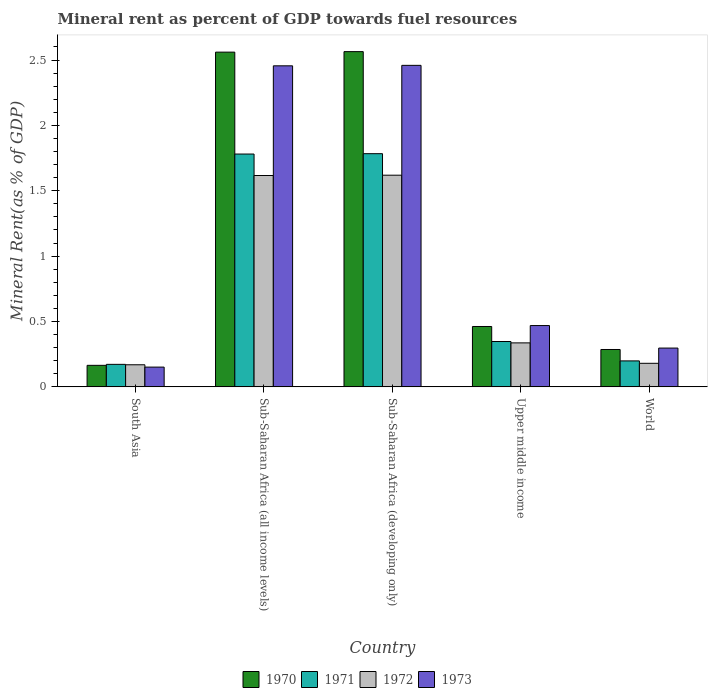How many groups of bars are there?
Provide a succinct answer. 5. How many bars are there on the 2nd tick from the right?
Offer a terse response. 4. What is the label of the 1st group of bars from the left?
Make the answer very short. South Asia. What is the mineral rent in 1971 in Sub-Saharan Africa (developing only)?
Your answer should be compact. 1.78. Across all countries, what is the maximum mineral rent in 1970?
Keep it short and to the point. 2.56. Across all countries, what is the minimum mineral rent in 1971?
Ensure brevity in your answer.  0.17. In which country was the mineral rent in 1971 maximum?
Offer a terse response. Sub-Saharan Africa (developing only). In which country was the mineral rent in 1973 minimum?
Keep it short and to the point. South Asia. What is the total mineral rent in 1972 in the graph?
Your response must be concise. 3.92. What is the difference between the mineral rent in 1973 in South Asia and that in World?
Provide a short and direct response. -0.15. What is the difference between the mineral rent in 1970 in South Asia and the mineral rent in 1972 in Sub-Saharan Africa (all income levels)?
Offer a terse response. -1.45. What is the average mineral rent in 1972 per country?
Offer a terse response. 0.78. What is the difference between the mineral rent of/in 1970 and mineral rent of/in 1972 in Upper middle income?
Ensure brevity in your answer.  0.13. What is the ratio of the mineral rent in 1972 in Sub-Saharan Africa (all income levels) to that in Upper middle income?
Provide a short and direct response. 4.81. Is the difference between the mineral rent in 1970 in Sub-Saharan Africa (developing only) and Upper middle income greater than the difference between the mineral rent in 1972 in Sub-Saharan Africa (developing only) and Upper middle income?
Provide a short and direct response. Yes. What is the difference between the highest and the second highest mineral rent in 1972?
Provide a succinct answer. -1.28. What is the difference between the highest and the lowest mineral rent in 1970?
Make the answer very short. 2.4. Is the sum of the mineral rent in 1971 in South Asia and Sub-Saharan Africa (all income levels) greater than the maximum mineral rent in 1970 across all countries?
Make the answer very short. No. What does the 3rd bar from the left in Sub-Saharan Africa (developing only) represents?
Offer a terse response. 1972. What does the 2nd bar from the right in Sub-Saharan Africa (all income levels) represents?
Offer a very short reply. 1972. How many bars are there?
Keep it short and to the point. 20. Are all the bars in the graph horizontal?
Offer a very short reply. No. What is the difference between two consecutive major ticks on the Y-axis?
Offer a terse response. 0.5. What is the title of the graph?
Offer a very short reply. Mineral rent as percent of GDP towards fuel resources. Does "1973" appear as one of the legend labels in the graph?
Your answer should be compact. Yes. What is the label or title of the Y-axis?
Your response must be concise. Mineral Rent(as % of GDP). What is the Mineral Rent(as % of GDP) of 1970 in South Asia?
Offer a terse response. 0.16. What is the Mineral Rent(as % of GDP) in 1971 in South Asia?
Make the answer very short. 0.17. What is the Mineral Rent(as % of GDP) in 1972 in South Asia?
Give a very brief answer. 0.17. What is the Mineral Rent(as % of GDP) in 1973 in South Asia?
Make the answer very short. 0.15. What is the Mineral Rent(as % of GDP) of 1970 in Sub-Saharan Africa (all income levels)?
Your answer should be very brief. 2.56. What is the Mineral Rent(as % of GDP) of 1971 in Sub-Saharan Africa (all income levels)?
Your answer should be very brief. 1.78. What is the Mineral Rent(as % of GDP) in 1972 in Sub-Saharan Africa (all income levels)?
Your answer should be compact. 1.62. What is the Mineral Rent(as % of GDP) in 1973 in Sub-Saharan Africa (all income levels)?
Provide a short and direct response. 2.46. What is the Mineral Rent(as % of GDP) of 1970 in Sub-Saharan Africa (developing only)?
Your answer should be very brief. 2.56. What is the Mineral Rent(as % of GDP) in 1971 in Sub-Saharan Africa (developing only)?
Offer a terse response. 1.78. What is the Mineral Rent(as % of GDP) of 1972 in Sub-Saharan Africa (developing only)?
Make the answer very short. 1.62. What is the Mineral Rent(as % of GDP) of 1973 in Sub-Saharan Africa (developing only)?
Provide a succinct answer. 2.46. What is the Mineral Rent(as % of GDP) of 1970 in Upper middle income?
Your answer should be compact. 0.46. What is the Mineral Rent(as % of GDP) in 1971 in Upper middle income?
Your answer should be compact. 0.35. What is the Mineral Rent(as % of GDP) of 1972 in Upper middle income?
Ensure brevity in your answer.  0.34. What is the Mineral Rent(as % of GDP) of 1973 in Upper middle income?
Keep it short and to the point. 0.47. What is the Mineral Rent(as % of GDP) in 1970 in World?
Your answer should be compact. 0.29. What is the Mineral Rent(as % of GDP) of 1971 in World?
Keep it short and to the point. 0.2. What is the Mineral Rent(as % of GDP) in 1972 in World?
Provide a short and direct response. 0.18. What is the Mineral Rent(as % of GDP) of 1973 in World?
Ensure brevity in your answer.  0.3. Across all countries, what is the maximum Mineral Rent(as % of GDP) in 1970?
Make the answer very short. 2.56. Across all countries, what is the maximum Mineral Rent(as % of GDP) of 1971?
Provide a short and direct response. 1.78. Across all countries, what is the maximum Mineral Rent(as % of GDP) in 1972?
Offer a terse response. 1.62. Across all countries, what is the maximum Mineral Rent(as % of GDP) in 1973?
Keep it short and to the point. 2.46. Across all countries, what is the minimum Mineral Rent(as % of GDP) in 1970?
Your answer should be compact. 0.16. Across all countries, what is the minimum Mineral Rent(as % of GDP) of 1971?
Your response must be concise. 0.17. Across all countries, what is the minimum Mineral Rent(as % of GDP) of 1972?
Your response must be concise. 0.17. Across all countries, what is the minimum Mineral Rent(as % of GDP) of 1973?
Keep it short and to the point. 0.15. What is the total Mineral Rent(as % of GDP) of 1970 in the graph?
Offer a very short reply. 6.04. What is the total Mineral Rent(as % of GDP) of 1971 in the graph?
Your answer should be compact. 4.28. What is the total Mineral Rent(as % of GDP) in 1972 in the graph?
Your answer should be very brief. 3.92. What is the total Mineral Rent(as % of GDP) of 1973 in the graph?
Ensure brevity in your answer.  5.83. What is the difference between the Mineral Rent(as % of GDP) in 1970 in South Asia and that in Sub-Saharan Africa (all income levels)?
Ensure brevity in your answer.  -2.4. What is the difference between the Mineral Rent(as % of GDP) of 1971 in South Asia and that in Sub-Saharan Africa (all income levels)?
Give a very brief answer. -1.61. What is the difference between the Mineral Rent(as % of GDP) of 1972 in South Asia and that in Sub-Saharan Africa (all income levels)?
Provide a short and direct response. -1.45. What is the difference between the Mineral Rent(as % of GDP) of 1973 in South Asia and that in Sub-Saharan Africa (all income levels)?
Ensure brevity in your answer.  -2.3. What is the difference between the Mineral Rent(as % of GDP) of 1970 in South Asia and that in Sub-Saharan Africa (developing only)?
Provide a short and direct response. -2.4. What is the difference between the Mineral Rent(as % of GDP) in 1971 in South Asia and that in Sub-Saharan Africa (developing only)?
Keep it short and to the point. -1.61. What is the difference between the Mineral Rent(as % of GDP) in 1972 in South Asia and that in Sub-Saharan Africa (developing only)?
Keep it short and to the point. -1.45. What is the difference between the Mineral Rent(as % of GDP) of 1973 in South Asia and that in Sub-Saharan Africa (developing only)?
Your answer should be very brief. -2.31. What is the difference between the Mineral Rent(as % of GDP) of 1970 in South Asia and that in Upper middle income?
Ensure brevity in your answer.  -0.3. What is the difference between the Mineral Rent(as % of GDP) of 1971 in South Asia and that in Upper middle income?
Provide a succinct answer. -0.17. What is the difference between the Mineral Rent(as % of GDP) in 1972 in South Asia and that in Upper middle income?
Your answer should be very brief. -0.17. What is the difference between the Mineral Rent(as % of GDP) of 1973 in South Asia and that in Upper middle income?
Make the answer very short. -0.32. What is the difference between the Mineral Rent(as % of GDP) of 1970 in South Asia and that in World?
Provide a succinct answer. -0.12. What is the difference between the Mineral Rent(as % of GDP) of 1971 in South Asia and that in World?
Give a very brief answer. -0.03. What is the difference between the Mineral Rent(as % of GDP) in 1972 in South Asia and that in World?
Your answer should be very brief. -0.01. What is the difference between the Mineral Rent(as % of GDP) of 1973 in South Asia and that in World?
Make the answer very short. -0.15. What is the difference between the Mineral Rent(as % of GDP) of 1970 in Sub-Saharan Africa (all income levels) and that in Sub-Saharan Africa (developing only)?
Make the answer very short. -0. What is the difference between the Mineral Rent(as % of GDP) in 1971 in Sub-Saharan Africa (all income levels) and that in Sub-Saharan Africa (developing only)?
Provide a short and direct response. -0. What is the difference between the Mineral Rent(as % of GDP) in 1972 in Sub-Saharan Africa (all income levels) and that in Sub-Saharan Africa (developing only)?
Your answer should be compact. -0. What is the difference between the Mineral Rent(as % of GDP) in 1973 in Sub-Saharan Africa (all income levels) and that in Sub-Saharan Africa (developing only)?
Offer a very short reply. -0. What is the difference between the Mineral Rent(as % of GDP) of 1970 in Sub-Saharan Africa (all income levels) and that in Upper middle income?
Offer a terse response. 2.1. What is the difference between the Mineral Rent(as % of GDP) in 1971 in Sub-Saharan Africa (all income levels) and that in Upper middle income?
Offer a very short reply. 1.43. What is the difference between the Mineral Rent(as % of GDP) in 1972 in Sub-Saharan Africa (all income levels) and that in Upper middle income?
Ensure brevity in your answer.  1.28. What is the difference between the Mineral Rent(as % of GDP) in 1973 in Sub-Saharan Africa (all income levels) and that in Upper middle income?
Make the answer very short. 1.99. What is the difference between the Mineral Rent(as % of GDP) of 1970 in Sub-Saharan Africa (all income levels) and that in World?
Offer a very short reply. 2.27. What is the difference between the Mineral Rent(as % of GDP) in 1971 in Sub-Saharan Africa (all income levels) and that in World?
Offer a very short reply. 1.58. What is the difference between the Mineral Rent(as % of GDP) of 1972 in Sub-Saharan Africa (all income levels) and that in World?
Your answer should be compact. 1.44. What is the difference between the Mineral Rent(as % of GDP) in 1973 in Sub-Saharan Africa (all income levels) and that in World?
Provide a short and direct response. 2.16. What is the difference between the Mineral Rent(as % of GDP) of 1970 in Sub-Saharan Africa (developing only) and that in Upper middle income?
Ensure brevity in your answer.  2.1. What is the difference between the Mineral Rent(as % of GDP) of 1971 in Sub-Saharan Africa (developing only) and that in Upper middle income?
Provide a short and direct response. 1.44. What is the difference between the Mineral Rent(as % of GDP) of 1972 in Sub-Saharan Africa (developing only) and that in Upper middle income?
Your response must be concise. 1.28. What is the difference between the Mineral Rent(as % of GDP) of 1973 in Sub-Saharan Africa (developing only) and that in Upper middle income?
Keep it short and to the point. 1.99. What is the difference between the Mineral Rent(as % of GDP) of 1970 in Sub-Saharan Africa (developing only) and that in World?
Provide a short and direct response. 2.28. What is the difference between the Mineral Rent(as % of GDP) of 1971 in Sub-Saharan Africa (developing only) and that in World?
Provide a short and direct response. 1.58. What is the difference between the Mineral Rent(as % of GDP) of 1972 in Sub-Saharan Africa (developing only) and that in World?
Offer a terse response. 1.44. What is the difference between the Mineral Rent(as % of GDP) in 1973 in Sub-Saharan Africa (developing only) and that in World?
Your response must be concise. 2.16. What is the difference between the Mineral Rent(as % of GDP) in 1970 in Upper middle income and that in World?
Give a very brief answer. 0.18. What is the difference between the Mineral Rent(as % of GDP) of 1971 in Upper middle income and that in World?
Ensure brevity in your answer.  0.15. What is the difference between the Mineral Rent(as % of GDP) in 1972 in Upper middle income and that in World?
Ensure brevity in your answer.  0.16. What is the difference between the Mineral Rent(as % of GDP) of 1973 in Upper middle income and that in World?
Your answer should be very brief. 0.17. What is the difference between the Mineral Rent(as % of GDP) in 1970 in South Asia and the Mineral Rent(as % of GDP) in 1971 in Sub-Saharan Africa (all income levels)?
Make the answer very short. -1.62. What is the difference between the Mineral Rent(as % of GDP) in 1970 in South Asia and the Mineral Rent(as % of GDP) in 1972 in Sub-Saharan Africa (all income levels)?
Provide a succinct answer. -1.45. What is the difference between the Mineral Rent(as % of GDP) of 1970 in South Asia and the Mineral Rent(as % of GDP) of 1973 in Sub-Saharan Africa (all income levels)?
Provide a short and direct response. -2.29. What is the difference between the Mineral Rent(as % of GDP) in 1971 in South Asia and the Mineral Rent(as % of GDP) in 1972 in Sub-Saharan Africa (all income levels)?
Your response must be concise. -1.44. What is the difference between the Mineral Rent(as % of GDP) of 1971 in South Asia and the Mineral Rent(as % of GDP) of 1973 in Sub-Saharan Africa (all income levels)?
Provide a short and direct response. -2.28. What is the difference between the Mineral Rent(as % of GDP) of 1972 in South Asia and the Mineral Rent(as % of GDP) of 1973 in Sub-Saharan Africa (all income levels)?
Your answer should be very brief. -2.29. What is the difference between the Mineral Rent(as % of GDP) of 1970 in South Asia and the Mineral Rent(as % of GDP) of 1971 in Sub-Saharan Africa (developing only)?
Keep it short and to the point. -1.62. What is the difference between the Mineral Rent(as % of GDP) in 1970 in South Asia and the Mineral Rent(as % of GDP) in 1972 in Sub-Saharan Africa (developing only)?
Offer a very short reply. -1.45. What is the difference between the Mineral Rent(as % of GDP) in 1970 in South Asia and the Mineral Rent(as % of GDP) in 1973 in Sub-Saharan Africa (developing only)?
Offer a terse response. -2.29. What is the difference between the Mineral Rent(as % of GDP) of 1971 in South Asia and the Mineral Rent(as % of GDP) of 1972 in Sub-Saharan Africa (developing only)?
Your answer should be compact. -1.45. What is the difference between the Mineral Rent(as % of GDP) of 1971 in South Asia and the Mineral Rent(as % of GDP) of 1973 in Sub-Saharan Africa (developing only)?
Make the answer very short. -2.29. What is the difference between the Mineral Rent(as % of GDP) of 1972 in South Asia and the Mineral Rent(as % of GDP) of 1973 in Sub-Saharan Africa (developing only)?
Offer a terse response. -2.29. What is the difference between the Mineral Rent(as % of GDP) in 1970 in South Asia and the Mineral Rent(as % of GDP) in 1971 in Upper middle income?
Provide a succinct answer. -0.18. What is the difference between the Mineral Rent(as % of GDP) in 1970 in South Asia and the Mineral Rent(as % of GDP) in 1972 in Upper middle income?
Your answer should be compact. -0.17. What is the difference between the Mineral Rent(as % of GDP) of 1970 in South Asia and the Mineral Rent(as % of GDP) of 1973 in Upper middle income?
Give a very brief answer. -0.3. What is the difference between the Mineral Rent(as % of GDP) in 1971 in South Asia and the Mineral Rent(as % of GDP) in 1972 in Upper middle income?
Offer a very short reply. -0.16. What is the difference between the Mineral Rent(as % of GDP) of 1971 in South Asia and the Mineral Rent(as % of GDP) of 1973 in Upper middle income?
Offer a very short reply. -0.3. What is the difference between the Mineral Rent(as % of GDP) of 1972 in South Asia and the Mineral Rent(as % of GDP) of 1973 in Upper middle income?
Keep it short and to the point. -0.3. What is the difference between the Mineral Rent(as % of GDP) in 1970 in South Asia and the Mineral Rent(as % of GDP) in 1971 in World?
Make the answer very short. -0.03. What is the difference between the Mineral Rent(as % of GDP) in 1970 in South Asia and the Mineral Rent(as % of GDP) in 1972 in World?
Your answer should be compact. -0.02. What is the difference between the Mineral Rent(as % of GDP) of 1970 in South Asia and the Mineral Rent(as % of GDP) of 1973 in World?
Your answer should be very brief. -0.13. What is the difference between the Mineral Rent(as % of GDP) in 1971 in South Asia and the Mineral Rent(as % of GDP) in 1972 in World?
Offer a very short reply. -0.01. What is the difference between the Mineral Rent(as % of GDP) in 1971 in South Asia and the Mineral Rent(as % of GDP) in 1973 in World?
Your answer should be very brief. -0.12. What is the difference between the Mineral Rent(as % of GDP) in 1972 in South Asia and the Mineral Rent(as % of GDP) in 1973 in World?
Provide a short and direct response. -0.13. What is the difference between the Mineral Rent(as % of GDP) in 1970 in Sub-Saharan Africa (all income levels) and the Mineral Rent(as % of GDP) in 1971 in Sub-Saharan Africa (developing only)?
Provide a succinct answer. 0.78. What is the difference between the Mineral Rent(as % of GDP) in 1970 in Sub-Saharan Africa (all income levels) and the Mineral Rent(as % of GDP) in 1973 in Sub-Saharan Africa (developing only)?
Your answer should be compact. 0.1. What is the difference between the Mineral Rent(as % of GDP) of 1971 in Sub-Saharan Africa (all income levels) and the Mineral Rent(as % of GDP) of 1972 in Sub-Saharan Africa (developing only)?
Offer a terse response. 0.16. What is the difference between the Mineral Rent(as % of GDP) of 1971 in Sub-Saharan Africa (all income levels) and the Mineral Rent(as % of GDP) of 1973 in Sub-Saharan Africa (developing only)?
Keep it short and to the point. -0.68. What is the difference between the Mineral Rent(as % of GDP) in 1972 in Sub-Saharan Africa (all income levels) and the Mineral Rent(as % of GDP) in 1973 in Sub-Saharan Africa (developing only)?
Provide a succinct answer. -0.84. What is the difference between the Mineral Rent(as % of GDP) in 1970 in Sub-Saharan Africa (all income levels) and the Mineral Rent(as % of GDP) in 1971 in Upper middle income?
Your response must be concise. 2.21. What is the difference between the Mineral Rent(as % of GDP) in 1970 in Sub-Saharan Africa (all income levels) and the Mineral Rent(as % of GDP) in 1972 in Upper middle income?
Offer a terse response. 2.22. What is the difference between the Mineral Rent(as % of GDP) of 1970 in Sub-Saharan Africa (all income levels) and the Mineral Rent(as % of GDP) of 1973 in Upper middle income?
Ensure brevity in your answer.  2.09. What is the difference between the Mineral Rent(as % of GDP) in 1971 in Sub-Saharan Africa (all income levels) and the Mineral Rent(as % of GDP) in 1972 in Upper middle income?
Your answer should be compact. 1.44. What is the difference between the Mineral Rent(as % of GDP) in 1971 in Sub-Saharan Africa (all income levels) and the Mineral Rent(as % of GDP) in 1973 in Upper middle income?
Keep it short and to the point. 1.31. What is the difference between the Mineral Rent(as % of GDP) of 1972 in Sub-Saharan Africa (all income levels) and the Mineral Rent(as % of GDP) of 1973 in Upper middle income?
Keep it short and to the point. 1.15. What is the difference between the Mineral Rent(as % of GDP) in 1970 in Sub-Saharan Africa (all income levels) and the Mineral Rent(as % of GDP) in 1971 in World?
Make the answer very short. 2.36. What is the difference between the Mineral Rent(as % of GDP) in 1970 in Sub-Saharan Africa (all income levels) and the Mineral Rent(as % of GDP) in 1972 in World?
Make the answer very short. 2.38. What is the difference between the Mineral Rent(as % of GDP) in 1970 in Sub-Saharan Africa (all income levels) and the Mineral Rent(as % of GDP) in 1973 in World?
Give a very brief answer. 2.26. What is the difference between the Mineral Rent(as % of GDP) of 1971 in Sub-Saharan Africa (all income levels) and the Mineral Rent(as % of GDP) of 1972 in World?
Offer a terse response. 1.6. What is the difference between the Mineral Rent(as % of GDP) in 1971 in Sub-Saharan Africa (all income levels) and the Mineral Rent(as % of GDP) in 1973 in World?
Provide a short and direct response. 1.48. What is the difference between the Mineral Rent(as % of GDP) in 1972 in Sub-Saharan Africa (all income levels) and the Mineral Rent(as % of GDP) in 1973 in World?
Keep it short and to the point. 1.32. What is the difference between the Mineral Rent(as % of GDP) of 1970 in Sub-Saharan Africa (developing only) and the Mineral Rent(as % of GDP) of 1971 in Upper middle income?
Make the answer very short. 2.22. What is the difference between the Mineral Rent(as % of GDP) of 1970 in Sub-Saharan Africa (developing only) and the Mineral Rent(as % of GDP) of 1972 in Upper middle income?
Offer a terse response. 2.23. What is the difference between the Mineral Rent(as % of GDP) of 1970 in Sub-Saharan Africa (developing only) and the Mineral Rent(as % of GDP) of 1973 in Upper middle income?
Make the answer very short. 2.1. What is the difference between the Mineral Rent(as % of GDP) in 1971 in Sub-Saharan Africa (developing only) and the Mineral Rent(as % of GDP) in 1972 in Upper middle income?
Your answer should be compact. 1.45. What is the difference between the Mineral Rent(as % of GDP) of 1971 in Sub-Saharan Africa (developing only) and the Mineral Rent(as % of GDP) of 1973 in Upper middle income?
Give a very brief answer. 1.31. What is the difference between the Mineral Rent(as % of GDP) of 1972 in Sub-Saharan Africa (developing only) and the Mineral Rent(as % of GDP) of 1973 in Upper middle income?
Give a very brief answer. 1.15. What is the difference between the Mineral Rent(as % of GDP) of 1970 in Sub-Saharan Africa (developing only) and the Mineral Rent(as % of GDP) of 1971 in World?
Make the answer very short. 2.37. What is the difference between the Mineral Rent(as % of GDP) of 1970 in Sub-Saharan Africa (developing only) and the Mineral Rent(as % of GDP) of 1972 in World?
Provide a succinct answer. 2.38. What is the difference between the Mineral Rent(as % of GDP) of 1970 in Sub-Saharan Africa (developing only) and the Mineral Rent(as % of GDP) of 1973 in World?
Ensure brevity in your answer.  2.27. What is the difference between the Mineral Rent(as % of GDP) of 1971 in Sub-Saharan Africa (developing only) and the Mineral Rent(as % of GDP) of 1972 in World?
Offer a terse response. 1.6. What is the difference between the Mineral Rent(as % of GDP) of 1971 in Sub-Saharan Africa (developing only) and the Mineral Rent(as % of GDP) of 1973 in World?
Your answer should be compact. 1.49. What is the difference between the Mineral Rent(as % of GDP) of 1972 in Sub-Saharan Africa (developing only) and the Mineral Rent(as % of GDP) of 1973 in World?
Your response must be concise. 1.32. What is the difference between the Mineral Rent(as % of GDP) in 1970 in Upper middle income and the Mineral Rent(as % of GDP) in 1971 in World?
Make the answer very short. 0.26. What is the difference between the Mineral Rent(as % of GDP) of 1970 in Upper middle income and the Mineral Rent(as % of GDP) of 1972 in World?
Your answer should be very brief. 0.28. What is the difference between the Mineral Rent(as % of GDP) in 1970 in Upper middle income and the Mineral Rent(as % of GDP) in 1973 in World?
Your answer should be very brief. 0.17. What is the difference between the Mineral Rent(as % of GDP) in 1971 in Upper middle income and the Mineral Rent(as % of GDP) in 1973 in World?
Provide a short and direct response. 0.05. What is the difference between the Mineral Rent(as % of GDP) in 1972 in Upper middle income and the Mineral Rent(as % of GDP) in 1973 in World?
Keep it short and to the point. 0.04. What is the average Mineral Rent(as % of GDP) of 1970 per country?
Offer a terse response. 1.21. What is the average Mineral Rent(as % of GDP) of 1971 per country?
Offer a very short reply. 0.86. What is the average Mineral Rent(as % of GDP) in 1972 per country?
Your response must be concise. 0.78. What is the average Mineral Rent(as % of GDP) in 1973 per country?
Make the answer very short. 1.17. What is the difference between the Mineral Rent(as % of GDP) of 1970 and Mineral Rent(as % of GDP) of 1971 in South Asia?
Your answer should be very brief. -0.01. What is the difference between the Mineral Rent(as % of GDP) in 1970 and Mineral Rent(as % of GDP) in 1972 in South Asia?
Ensure brevity in your answer.  -0. What is the difference between the Mineral Rent(as % of GDP) of 1970 and Mineral Rent(as % of GDP) of 1973 in South Asia?
Provide a succinct answer. 0.01. What is the difference between the Mineral Rent(as % of GDP) of 1971 and Mineral Rent(as % of GDP) of 1972 in South Asia?
Your answer should be very brief. 0. What is the difference between the Mineral Rent(as % of GDP) in 1971 and Mineral Rent(as % of GDP) in 1973 in South Asia?
Your answer should be very brief. 0.02. What is the difference between the Mineral Rent(as % of GDP) in 1972 and Mineral Rent(as % of GDP) in 1973 in South Asia?
Give a very brief answer. 0.02. What is the difference between the Mineral Rent(as % of GDP) in 1970 and Mineral Rent(as % of GDP) in 1971 in Sub-Saharan Africa (all income levels)?
Your answer should be very brief. 0.78. What is the difference between the Mineral Rent(as % of GDP) in 1970 and Mineral Rent(as % of GDP) in 1972 in Sub-Saharan Africa (all income levels)?
Offer a terse response. 0.94. What is the difference between the Mineral Rent(as % of GDP) of 1970 and Mineral Rent(as % of GDP) of 1973 in Sub-Saharan Africa (all income levels)?
Your answer should be very brief. 0.1. What is the difference between the Mineral Rent(as % of GDP) of 1971 and Mineral Rent(as % of GDP) of 1972 in Sub-Saharan Africa (all income levels)?
Your answer should be very brief. 0.16. What is the difference between the Mineral Rent(as % of GDP) of 1971 and Mineral Rent(as % of GDP) of 1973 in Sub-Saharan Africa (all income levels)?
Your response must be concise. -0.67. What is the difference between the Mineral Rent(as % of GDP) in 1972 and Mineral Rent(as % of GDP) in 1973 in Sub-Saharan Africa (all income levels)?
Ensure brevity in your answer.  -0.84. What is the difference between the Mineral Rent(as % of GDP) of 1970 and Mineral Rent(as % of GDP) of 1971 in Sub-Saharan Africa (developing only)?
Offer a very short reply. 0.78. What is the difference between the Mineral Rent(as % of GDP) of 1970 and Mineral Rent(as % of GDP) of 1972 in Sub-Saharan Africa (developing only)?
Give a very brief answer. 0.95. What is the difference between the Mineral Rent(as % of GDP) of 1970 and Mineral Rent(as % of GDP) of 1973 in Sub-Saharan Africa (developing only)?
Make the answer very short. 0.1. What is the difference between the Mineral Rent(as % of GDP) in 1971 and Mineral Rent(as % of GDP) in 1972 in Sub-Saharan Africa (developing only)?
Keep it short and to the point. 0.16. What is the difference between the Mineral Rent(as % of GDP) of 1971 and Mineral Rent(as % of GDP) of 1973 in Sub-Saharan Africa (developing only)?
Provide a short and direct response. -0.68. What is the difference between the Mineral Rent(as % of GDP) of 1972 and Mineral Rent(as % of GDP) of 1973 in Sub-Saharan Africa (developing only)?
Ensure brevity in your answer.  -0.84. What is the difference between the Mineral Rent(as % of GDP) of 1970 and Mineral Rent(as % of GDP) of 1971 in Upper middle income?
Make the answer very short. 0.11. What is the difference between the Mineral Rent(as % of GDP) in 1970 and Mineral Rent(as % of GDP) in 1972 in Upper middle income?
Keep it short and to the point. 0.13. What is the difference between the Mineral Rent(as % of GDP) of 1970 and Mineral Rent(as % of GDP) of 1973 in Upper middle income?
Offer a terse response. -0.01. What is the difference between the Mineral Rent(as % of GDP) in 1971 and Mineral Rent(as % of GDP) in 1972 in Upper middle income?
Give a very brief answer. 0.01. What is the difference between the Mineral Rent(as % of GDP) in 1971 and Mineral Rent(as % of GDP) in 1973 in Upper middle income?
Offer a terse response. -0.12. What is the difference between the Mineral Rent(as % of GDP) of 1972 and Mineral Rent(as % of GDP) of 1973 in Upper middle income?
Your response must be concise. -0.13. What is the difference between the Mineral Rent(as % of GDP) of 1970 and Mineral Rent(as % of GDP) of 1971 in World?
Keep it short and to the point. 0.09. What is the difference between the Mineral Rent(as % of GDP) of 1970 and Mineral Rent(as % of GDP) of 1972 in World?
Make the answer very short. 0.11. What is the difference between the Mineral Rent(as % of GDP) in 1970 and Mineral Rent(as % of GDP) in 1973 in World?
Keep it short and to the point. -0.01. What is the difference between the Mineral Rent(as % of GDP) in 1971 and Mineral Rent(as % of GDP) in 1972 in World?
Provide a short and direct response. 0.02. What is the difference between the Mineral Rent(as % of GDP) in 1971 and Mineral Rent(as % of GDP) in 1973 in World?
Your answer should be compact. -0.1. What is the difference between the Mineral Rent(as % of GDP) in 1972 and Mineral Rent(as % of GDP) in 1973 in World?
Offer a terse response. -0.12. What is the ratio of the Mineral Rent(as % of GDP) of 1970 in South Asia to that in Sub-Saharan Africa (all income levels)?
Ensure brevity in your answer.  0.06. What is the ratio of the Mineral Rent(as % of GDP) in 1971 in South Asia to that in Sub-Saharan Africa (all income levels)?
Offer a terse response. 0.1. What is the ratio of the Mineral Rent(as % of GDP) in 1972 in South Asia to that in Sub-Saharan Africa (all income levels)?
Offer a very short reply. 0.1. What is the ratio of the Mineral Rent(as % of GDP) in 1973 in South Asia to that in Sub-Saharan Africa (all income levels)?
Ensure brevity in your answer.  0.06. What is the ratio of the Mineral Rent(as % of GDP) of 1970 in South Asia to that in Sub-Saharan Africa (developing only)?
Your answer should be very brief. 0.06. What is the ratio of the Mineral Rent(as % of GDP) in 1971 in South Asia to that in Sub-Saharan Africa (developing only)?
Give a very brief answer. 0.1. What is the ratio of the Mineral Rent(as % of GDP) in 1972 in South Asia to that in Sub-Saharan Africa (developing only)?
Provide a short and direct response. 0.1. What is the ratio of the Mineral Rent(as % of GDP) in 1973 in South Asia to that in Sub-Saharan Africa (developing only)?
Your answer should be compact. 0.06. What is the ratio of the Mineral Rent(as % of GDP) of 1970 in South Asia to that in Upper middle income?
Ensure brevity in your answer.  0.36. What is the ratio of the Mineral Rent(as % of GDP) of 1971 in South Asia to that in Upper middle income?
Keep it short and to the point. 0.5. What is the ratio of the Mineral Rent(as % of GDP) in 1972 in South Asia to that in Upper middle income?
Offer a very short reply. 0.5. What is the ratio of the Mineral Rent(as % of GDP) in 1973 in South Asia to that in Upper middle income?
Make the answer very short. 0.32. What is the ratio of the Mineral Rent(as % of GDP) in 1970 in South Asia to that in World?
Offer a terse response. 0.58. What is the ratio of the Mineral Rent(as % of GDP) in 1971 in South Asia to that in World?
Your response must be concise. 0.87. What is the ratio of the Mineral Rent(as % of GDP) of 1972 in South Asia to that in World?
Ensure brevity in your answer.  0.94. What is the ratio of the Mineral Rent(as % of GDP) in 1973 in South Asia to that in World?
Your answer should be compact. 0.51. What is the ratio of the Mineral Rent(as % of GDP) in 1972 in Sub-Saharan Africa (all income levels) to that in Sub-Saharan Africa (developing only)?
Your answer should be compact. 1. What is the ratio of the Mineral Rent(as % of GDP) of 1970 in Sub-Saharan Africa (all income levels) to that in Upper middle income?
Your answer should be very brief. 5.54. What is the ratio of the Mineral Rent(as % of GDP) of 1971 in Sub-Saharan Africa (all income levels) to that in Upper middle income?
Your response must be concise. 5.13. What is the ratio of the Mineral Rent(as % of GDP) in 1972 in Sub-Saharan Africa (all income levels) to that in Upper middle income?
Your answer should be very brief. 4.81. What is the ratio of the Mineral Rent(as % of GDP) of 1973 in Sub-Saharan Africa (all income levels) to that in Upper middle income?
Your response must be concise. 5.24. What is the ratio of the Mineral Rent(as % of GDP) of 1970 in Sub-Saharan Africa (all income levels) to that in World?
Give a very brief answer. 8.95. What is the ratio of the Mineral Rent(as % of GDP) of 1971 in Sub-Saharan Africa (all income levels) to that in World?
Offer a very short reply. 8.97. What is the ratio of the Mineral Rent(as % of GDP) in 1972 in Sub-Saharan Africa (all income levels) to that in World?
Your response must be concise. 8.97. What is the ratio of the Mineral Rent(as % of GDP) of 1973 in Sub-Saharan Africa (all income levels) to that in World?
Your answer should be very brief. 8.28. What is the ratio of the Mineral Rent(as % of GDP) in 1970 in Sub-Saharan Africa (developing only) to that in Upper middle income?
Your answer should be compact. 5.55. What is the ratio of the Mineral Rent(as % of GDP) in 1971 in Sub-Saharan Africa (developing only) to that in Upper middle income?
Keep it short and to the point. 5.14. What is the ratio of the Mineral Rent(as % of GDP) in 1972 in Sub-Saharan Africa (developing only) to that in Upper middle income?
Your response must be concise. 4.81. What is the ratio of the Mineral Rent(as % of GDP) of 1973 in Sub-Saharan Africa (developing only) to that in Upper middle income?
Your answer should be very brief. 5.24. What is the ratio of the Mineral Rent(as % of GDP) of 1970 in Sub-Saharan Africa (developing only) to that in World?
Your response must be concise. 8.97. What is the ratio of the Mineral Rent(as % of GDP) of 1971 in Sub-Saharan Africa (developing only) to that in World?
Give a very brief answer. 8.98. What is the ratio of the Mineral Rent(as % of GDP) of 1972 in Sub-Saharan Africa (developing only) to that in World?
Make the answer very short. 8.98. What is the ratio of the Mineral Rent(as % of GDP) in 1973 in Sub-Saharan Africa (developing only) to that in World?
Give a very brief answer. 8.29. What is the ratio of the Mineral Rent(as % of GDP) of 1970 in Upper middle income to that in World?
Make the answer very short. 1.62. What is the ratio of the Mineral Rent(as % of GDP) in 1971 in Upper middle income to that in World?
Ensure brevity in your answer.  1.75. What is the ratio of the Mineral Rent(as % of GDP) in 1972 in Upper middle income to that in World?
Your response must be concise. 1.87. What is the ratio of the Mineral Rent(as % of GDP) in 1973 in Upper middle income to that in World?
Ensure brevity in your answer.  1.58. What is the difference between the highest and the second highest Mineral Rent(as % of GDP) in 1970?
Make the answer very short. 0. What is the difference between the highest and the second highest Mineral Rent(as % of GDP) of 1971?
Offer a terse response. 0. What is the difference between the highest and the second highest Mineral Rent(as % of GDP) of 1972?
Make the answer very short. 0. What is the difference between the highest and the second highest Mineral Rent(as % of GDP) of 1973?
Ensure brevity in your answer.  0. What is the difference between the highest and the lowest Mineral Rent(as % of GDP) of 1970?
Give a very brief answer. 2.4. What is the difference between the highest and the lowest Mineral Rent(as % of GDP) of 1971?
Offer a very short reply. 1.61. What is the difference between the highest and the lowest Mineral Rent(as % of GDP) of 1972?
Offer a very short reply. 1.45. What is the difference between the highest and the lowest Mineral Rent(as % of GDP) in 1973?
Make the answer very short. 2.31. 